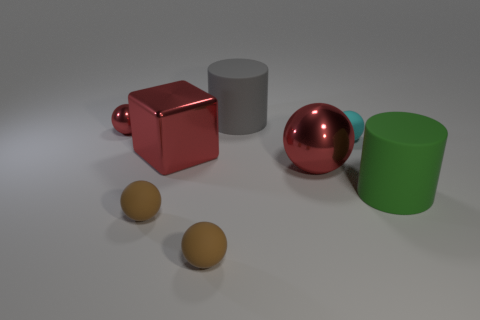Subtract all metallic balls. How many balls are left? 3 Subtract all gray cylinders. How many cylinders are left? 1 Subtract all purple balls. Subtract all green cylinders. How many balls are left? 5 Subtract all blue cylinders. How many blue cubes are left? 0 Subtract all small brown things. Subtract all brown spheres. How many objects are left? 4 Add 3 big metallic blocks. How many big metallic blocks are left? 4 Add 6 small balls. How many small balls exist? 10 Add 2 small gray blocks. How many objects exist? 10 Subtract 1 red spheres. How many objects are left? 7 Subtract all balls. How many objects are left? 3 